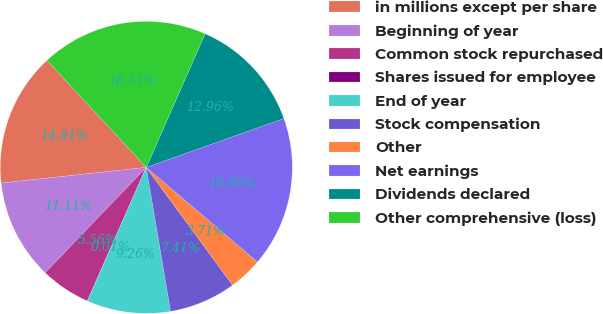Convert chart to OTSL. <chart><loc_0><loc_0><loc_500><loc_500><pie_chart><fcel>in millions except per share<fcel>Beginning of year<fcel>Common stock repurchased<fcel>Shares issued for employee<fcel>End of year<fcel>Stock compensation<fcel>Other<fcel>Net earnings<fcel>Dividends declared<fcel>Other comprehensive (loss)<nl><fcel>14.81%<fcel>11.11%<fcel>5.56%<fcel>0.01%<fcel>9.26%<fcel>7.41%<fcel>3.71%<fcel>16.66%<fcel>12.96%<fcel>18.51%<nl></chart> 